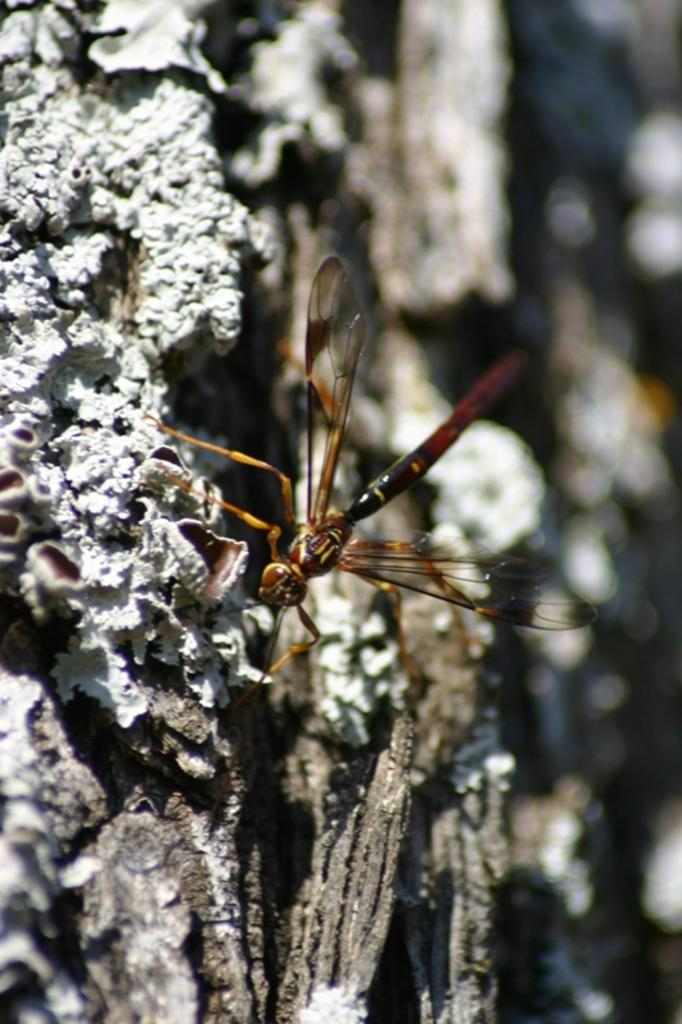What is the main subject of the image? There is a rock in the image. Is there anything on the rock? Yes, there is a dragonfly on the rock. Can you describe the background of the image? The background of the image is blurred. What book is the dragonfly reading on the rock? There is no book present in the image, and dragonflies do not have the ability to read. 